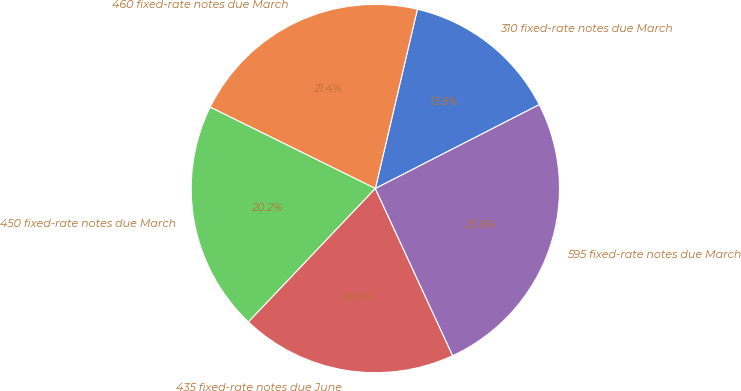Convert chart. <chart><loc_0><loc_0><loc_500><loc_500><pie_chart><fcel>310 fixed-rate notes due March<fcel>460 fixed-rate notes due March<fcel>450 fixed-rate notes due March<fcel>435 fixed-rate notes due June<fcel>595 fixed-rate notes due March<nl><fcel>13.81%<fcel>21.38%<fcel>20.19%<fcel>19.0%<fcel>25.63%<nl></chart> 